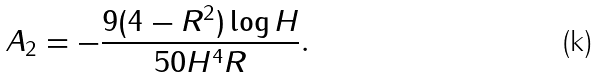<formula> <loc_0><loc_0><loc_500><loc_500>A _ { 2 } = - \frac { 9 ( 4 - R ^ { 2 } ) \log H } { 5 0 H ^ { 4 } R } .</formula> 